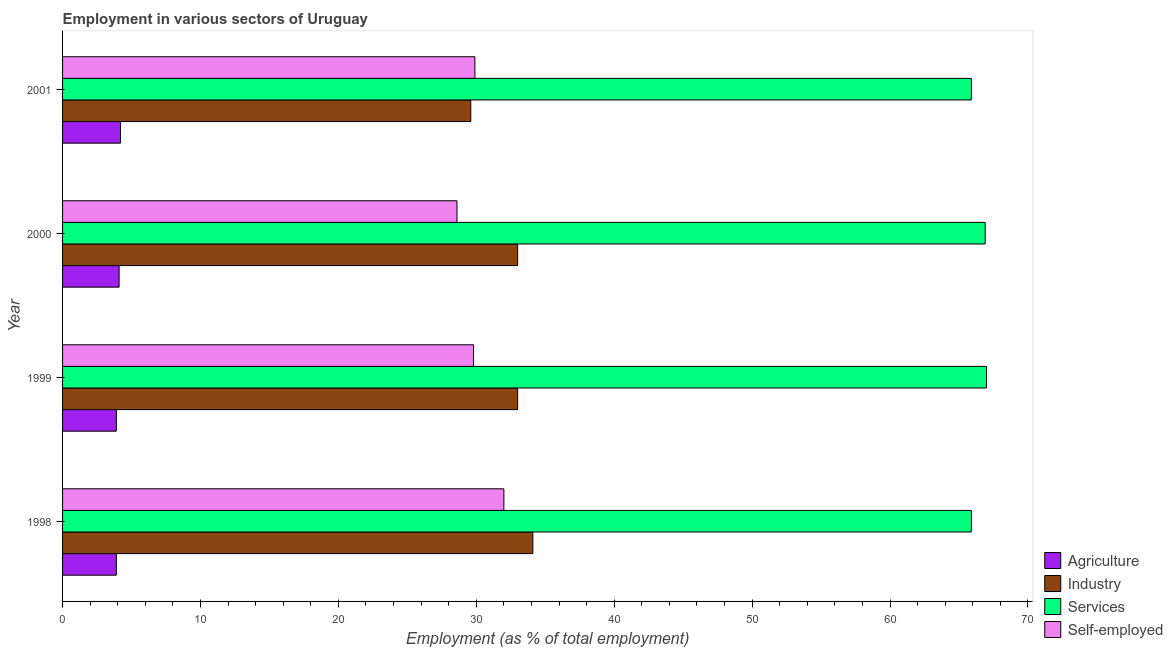How many different coloured bars are there?
Keep it short and to the point. 4. Are the number of bars per tick equal to the number of legend labels?
Offer a terse response. Yes. Are the number of bars on each tick of the Y-axis equal?
Provide a succinct answer. Yes. How many bars are there on the 2nd tick from the top?
Your answer should be compact. 4. How many bars are there on the 4th tick from the bottom?
Provide a short and direct response. 4. What is the percentage of workers in agriculture in 1998?
Your response must be concise. 3.9. Across all years, what is the minimum percentage of workers in services?
Your response must be concise. 65.9. In which year was the percentage of self employed workers minimum?
Provide a short and direct response. 2000. What is the total percentage of workers in industry in the graph?
Give a very brief answer. 129.7. What is the difference between the percentage of workers in agriculture in 1999 and the percentage of workers in services in 1998?
Offer a terse response. -62. What is the average percentage of self employed workers per year?
Make the answer very short. 30.07. In how many years, is the percentage of workers in agriculture greater than 32 %?
Make the answer very short. 0. Is the difference between the percentage of workers in agriculture in 2000 and 2001 greater than the difference between the percentage of self employed workers in 2000 and 2001?
Your answer should be very brief. Yes. In how many years, is the percentage of workers in services greater than the average percentage of workers in services taken over all years?
Your answer should be compact. 2. What does the 2nd bar from the top in 1998 represents?
Offer a very short reply. Services. What does the 3rd bar from the bottom in 1998 represents?
Provide a short and direct response. Services. How many bars are there?
Your answer should be compact. 16. How many years are there in the graph?
Your answer should be very brief. 4. Does the graph contain any zero values?
Your response must be concise. No. Does the graph contain grids?
Ensure brevity in your answer.  No. Where does the legend appear in the graph?
Your response must be concise. Bottom right. What is the title of the graph?
Make the answer very short. Employment in various sectors of Uruguay. Does "Quality of public administration" appear as one of the legend labels in the graph?
Ensure brevity in your answer.  No. What is the label or title of the X-axis?
Your answer should be compact. Employment (as % of total employment). What is the label or title of the Y-axis?
Keep it short and to the point. Year. What is the Employment (as % of total employment) of Agriculture in 1998?
Offer a very short reply. 3.9. What is the Employment (as % of total employment) of Industry in 1998?
Offer a very short reply. 34.1. What is the Employment (as % of total employment) of Services in 1998?
Your answer should be compact. 65.9. What is the Employment (as % of total employment) of Agriculture in 1999?
Keep it short and to the point. 3.9. What is the Employment (as % of total employment) in Industry in 1999?
Offer a terse response. 33. What is the Employment (as % of total employment) of Services in 1999?
Keep it short and to the point. 67. What is the Employment (as % of total employment) in Self-employed in 1999?
Offer a terse response. 29.8. What is the Employment (as % of total employment) of Agriculture in 2000?
Your answer should be very brief. 4.1. What is the Employment (as % of total employment) in Services in 2000?
Your answer should be very brief. 66.9. What is the Employment (as % of total employment) of Self-employed in 2000?
Keep it short and to the point. 28.6. What is the Employment (as % of total employment) of Agriculture in 2001?
Your response must be concise. 4.2. What is the Employment (as % of total employment) of Industry in 2001?
Give a very brief answer. 29.6. What is the Employment (as % of total employment) in Services in 2001?
Give a very brief answer. 65.9. What is the Employment (as % of total employment) in Self-employed in 2001?
Keep it short and to the point. 29.9. Across all years, what is the maximum Employment (as % of total employment) in Agriculture?
Provide a succinct answer. 4.2. Across all years, what is the maximum Employment (as % of total employment) of Industry?
Offer a very short reply. 34.1. Across all years, what is the minimum Employment (as % of total employment) in Agriculture?
Offer a very short reply. 3.9. Across all years, what is the minimum Employment (as % of total employment) of Industry?
Your answer should be very brief. 29.6. Across all years, what is the minimum Employment (as % of total employment) in Services?
Keep it short and to the point. 65.9. Across all years, what is the minimum Employment (as % of total employment) in Self-employed?
Make the answer very short. 28.6. What is the total Employment (as % of total employment) in Agriculture in the graph?
Your answer should be very brief. 16.1. What is the total Employment (as % of total employment) in Industry in the graph?
Your answer should be very brief. 129.7. What is the total Employment (as % of total employment) of Services in the graph?
Give a very brief answer. 265.7. What is the total Employment (as % of total employment) of Self-employed in the graph?
Make the answer very short. 120.3. What is the difference between the Employment (as % of total employment) in Industry in 1998 and that in 2000?
Provide a short and direct response. 1.1. What is the difference between the Employment (as % of total employment) in Services in 1998 and that in 2000?
Your response must be concise. -1. What is the difference between the Employment (as % of total employment) of Industry in 1998 and that in 2001?
Make the answer very short. 4.5. What is the difference between the Employment (as % of total employment) in Services in 1998 and that in 2001?
Give a very brief answer. 0. What is the difference between the Employment (as % of total employment) in Agriculture in 1999 and that in 2000?
Give a very brief answer. -0.2. What is the difference between the Employment (as % of total employment) in Industry in 1999 and that in 2000?
Keep it short and to the point. 0. What is the difference between the Employment (as % of total employment) of Industry in 2000 and that in 2001?
Keep it short and to the point. 3.4. What is the difference between the Employment (as % of total employment) of Services in 2000 and that in 2001?
Offer a very short reply. 1. What is the difference between the Employment (as % of total employment) of Self-employed in 2000 and that in 2001?
Provide a short and direct response. -1.3. What is the difference between the Employment (as % of total employment) of Agriculture in 1998 and the Employment (as % of total employment) of Industry in 1999?
Give a very brief answer. -29.1. What is the difference between the Employment (as % of total employment) in Agriculture in 1998 and the Employment (as % of total employment) in Services in 1999?
Offer a very short reply. -63.1. What is the difference between the Employment (as % of total employment) of Agriculture in 1998 and the Employment (as % of total employment) of Self-employed in 1999?
Offer a terse response. -25.9. What is the difference between the Employment (as % of total employment) in Industry in 1998 and the Employment (as % of total employment) in Services in 1999?
Ensure brevity in your answer.  -32.9. What is the difference between the Employment (as % of total employment) of Services in 1998 and the Employment (as % of total employment) of Self-employed in 1999?
Your answer should be very brief. 36.1. What is the difference between the Employment (as % of total employment) in Agriculture in 1998 and the Employment (as % of total employment) in Industry in 2000?
Offer a terse response. -29.1. What is the difference between the Employment (as % of total employment) of Agriculture in 1998 and the Employment (as % of total employment) of Services in 2000?
Keep it short and to the point. -63. What is the difference between the Employment (as % of total employment) in Agriculture in 1998 and the Employment (as % of total employment) in Self-employed in 2000?
Your answer should be compact. -24.7. What is the difference between the Employment (as % of total employment) of Industry in 1998 and the Employment (as % of total employment) of Services in 2000?
Ensure brevity in your answer.  -32.8. What is the difference between the Employment (as % of total employment) of Industry in 1998 and the Employment (as % of total employment) of Self-employed in 2000?
Give a very brief answer. 5.5. What is the difference between the Employment (as % of total employment) in Services in 1998 and the Employment (as % of total employment) in Self-employed in 2000?
Your answer should be very brief. 37.3. What is the difference between the Employment (as % of total employment) of Agriculture in 1998 and the Employment (as % of total employment) of Industry in 2001?
Your response must be concise. -25.7. What is the difference between the Employment (as % of total employment) in Agriculture in 1998 and the Employment (as % of total employment) in Services in 2001?
Your answer should be compact. -62. What is the difference between the Employment (as % of total employment) in Agriculture in 1998 and the Employment (as % of total employment) in Self-employed in 2001?
Provide a succinct answer. -26. What is the difference between the Employment (as % of total employment) in Industry in 1998 and the Employment (as % of total employment) in Services in 2001?
Offer a very short reply. -31.8. What is the difference between the Employment (as % of total employment) of Agriculture in 1999 and the Employment (as % of total employment) of Industry in 2000?
Make the answer very short. -29.1. What is the difference between the Employment (as % of total employment) of Agriculture in 1999 and the Employment (as % of total employment) of Services in 2000?
Keep it short and to the point. -63. What is the difference between the Employment (as % of total employment) in Agriculture in 1999 and the Employment (as % of total employment) in Self-employed in 2000?
Provide a succinct answer. -24.7. What is the difference between the Employment (as % of total employment) in Industry in 1999 and the Employment (as % of total employment) in Services in 2000?
Give a very brief answer. -33.9. What is the difference between the Employment (as % of total employment) of Services in 1999 and the Employment (as % of total employment) of Self-employed in 2000?
Keep it short and to the point. 38.4. What is the difference between the Employment (as % of total employment) in Agriculture in 1999 and the Employment (as % of total employment) in Industry in 2001?
Provide a succinct answer. -25.7. What is the difference between the Employment (as % of total employment) in Agriculture in 1999 and the Employment (as % of total employment) in Services in 2001?
Offer a terse response. -62. What is the difference between the Employment (as % of total employment) of Industry in 1999 and the Employment (as % of total employment) of Services in 2001?
Your response must be concise. -32.9. What is the difference between the Employment (as % of total employment) of Services in 1999 and the Employment (as % of total employment) of Self-employed in 2001?
Give a very brief answer. 37.1. What is the difference between the Employment (as % of total employment) of Agriculture in 2000 and the Employment (as % of total employment) of Industry in 2001?
Offer a terse response. -25.5. What is the difference between the Employment (as % of total employment) of Agriculture in 2000 and the Employment (as % of total employment) of Services in 2001?
Your response must be concise. -61.8. What is the difference between the Employment (as % of total employment) of Agriculture in 2000 and the Employment (as % of total employment) of Self-employed in 2001?
Provide a short and direct response. -25.8. What is the difference between the Employment (as % of total employment) in Industry in 2000 and the Employment (as % of total employment) in Services in 2001?
Your response must be concise. -32.9. What is the difference between the Employment (as % of total employment) of Services in 2000 and the Employment (as % of total employment) of Self-employed in 2001?
Your response must be concise. 37. What is the average Employment (as % of total employment) of Agriculture per year?
Make the answer very short. 4.03. What is the average Employment (as % of total employment) of Industry per year?
Make the answer very short. 32.42. What is the average Employment (as % of total employment) in Services per year?
Your answer should be very brief. 66.42. What is the average Employment (as % of total employment) in Self-employed per year?
Provide a succinct answer. 30.07. In the year 1998, what is the difference between the Employment (as % of total employment) of Agriculture and Employment (as % of total employment) of Industry?
Make the answer very short. -30.2. In the year 1998, what is the difference between the Employment (as % of total employment) in Agriculture and Employment (as % of total employment) in Services?
Offer a terse response. -62. In the year 1998, what is the difference between the Employment (as % of total employment) in Agriculture and Employment (as % of total employment) in Self-employed?
Provide a succinct answer. -28.1. In the year 1998, what is the difference between the Employment (as % of total employment) of Industry and Employment (as % of total employment) of Services?
Ensure brevity in your answer.  -31.8. In the year 1998, what is the difference between the Employment (as % of total employment) of Industry and Employment (as % of total employment) of Self-employed?
Keep it short and to the point. 2.1. In the year 1998, what is the difference between the Employment (as % of total employment) of Services and Employment (as % of total employment) of Self-employed?
Your response must be concise. 33.9. In the year 1999, what is the difference between the Employment (as % of total employment) in Agriculture and Employment (as % of total employment) in Industry?
Provide a short and direct response. -29.1. In the year 1999, what is the difference between the Employment (as % of total employment) of Agriculture and Employment (as % of total employment) of Services?
Give a very brief answer. -63.1. In the year 1999, what is the difference between the Employment (as % of total employment) in Agriculture and Employment (as % of total employment) in Self-employed?
Provide a short and direct response. -25.9. In the year 1999, what is the difference between the Employment (as % of total employment) of Industry and Employment (as % of total employment) of Services?
Provide a short and direct response. -34. In the year 1999, what is the difference between the Employment (as % of total employment) of Industry and Employment (as % of total employment) of Self-employed?
Your response must be concise. 3.2. In the year 1999, what is the difference between the Employment (as % of total employment) of Services and Employment (as % of total employment) of Self-employed?
Offer a very short reply. 37.2. In the year 2000, what is the difference between the Employment (as % of total employment) of Agriculture and Employment (as % of total employment) of Industry?
Your answer should be very brief. -28.9. In the year 2000, what is the difference between the Employment (as % of total employment) in Agriculture and Employment (as % of total employment) in Services?
Offer a very short reply. -62.8. In the year 2000, what is the difference between the Employment (as % of total employment) in Agriculture and Employment (as % of total employment) in Self-employed?
Provide a succinct answer. -24.5. In the year 2000, what is the difference between the Employment (as % of total employment) of Industry and Employment (as % of total employment) of Services?
Your response must be concise. -33.9. In the year 2000, what is the difference between the Employment (as % of total employment) in Services and Employment (as % of total employment) in Self-employed?
Provide a short and direct response. 38.3. In the year 2001, what is the difference between the Employment (as % of total employment) in Agriculture and Employment (as % of total employment) in Industry?
Your answer should be very brief. -25.4. In the year 2001, what is the difference between the Employment (as % of total employment) in Agriculture and Employment (as % of total employment) in Services?
Offer a terse response. -61.7. In the year 2001, what is the difference between the Employment (as % of total employment) in Agriculture and Employment (as % of total employment) in Self-employed?
Your response must be concise. -25.7. In the year 2001, what is the difference between the Employment (as % of total employment) of Industry and Employment (as % of total employment) of Services?
Offer a terse response. -36.3. In the year 2001, what is the difference between the Employment (as % of total employment) of Services and Employment (as % of total employment) of Self-employed?
Ensure brevity in your answer.  36. What is the ratio of the Employment (as % of total employment) of Industry in 1998 to that in 1999?
Offer a terse response. 1.03. What is the ratio of the Employment (as % of total employment) in Services in 1998 to that in 1999?
Provide a succinct answer. 0.98. What is the ratio of the Employment (as % of total employment) of Self-employed in 1998 to that in 1999?
Your answer should be compact. 1.07. What is the ratio of the Employment (as % of total employment) in Agriculture in 1998 to that in 2000?
Your response must be concise. 0.95. What is the ratio of the Employment (as % of total employment) in Services in 1998 to that in 2000?
Provide a succinct answer. 0.99. What is the ratio of the Employment (as % of total employment) of Self-employed in 1998 to that in 2000?
Provide a succinct answer. 1.12. What is the ratio of the Employment (as % of total employment) in Agriculture in 1998 to that in 2001?
Give a very brief answer. 0.93. What is the ratio of the Employment (as % of total employment) of Industry in 1998 to that in 2001?
Your answer should be compact. 1.15. What is the ratio of the Employment (as % of total employment) of Self-employed in 1998 to that in 2001?
Provide a succinct answer. 1.07. What is the ratio of the Employment (as % of total employment) in Agriculture in 1999 to that in 2000?
Provide a succinct answer. 0.95. What is the ratio of the Employment (as % of total employment) of Services in 1999 to that in 2000?
Provide a succinct answer. 1. What is the ratio of the Employment (as % of total employment) in Self-employed in 1999 to that in 2000?
Provide a short and direct response. 1.04. What is the ratio of the Employment (as % of total employment) of Industry in 1999 to that in 2001?
Offer a very short reply. 1.11. What is the ratio of the Employment (as % of total employment) of Services in 1999 to that in 2001?
Keep it short and to the point. 1.02. What is the ratio of the Employment (as % of total employment) of Agriculture in 2000 to that in 2001?
Provide a short and direct response. 0.98. What is the ratio of the Employment (as % of total employment) of Industry in 2000 to that in 2001?
Ensure brevity in your answer.  1.11. What is the ratio of the Employment (as % of total employment) in Services in 2000 to that in 2001?
Your response must be concise. 1.02. What is the ratio of the Employment (as % of total employment) in Self-employed in 2000 to that in 2001?
Your response must be concise. 0.96. What is the difference between the highest and the second highest Employment (as % of total employment) in Agriculture?
Make the answer very short. 0.1. What is the difference between the highest and the second highest Employment (as % of total employment) of Industry?
Give a very brief answer. 1.1. What is the difference between the highest and the second highest Employment (as % of total employment) in Services?
Your answer should be very brief. 0.1. What is the difference between the highest and the second highest Employment (as % of total employment) in Self-employed?
Offer a terse response. 2.1. What is the difference between the highest and the lowest Employment (as % of total employment) of Agriculture?
Your answer should be very brief. 0.3. What is the difference between the highest and the lowest Employment (as % of total employment) in Industry?
Offer a very short reply. 4.5. 